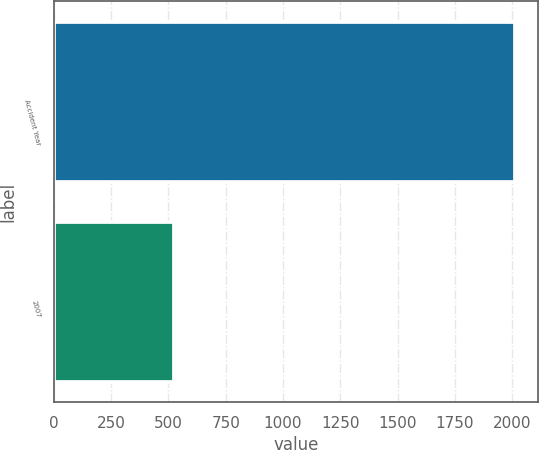Convert chart. <chart><loc_0><loc_0><loc_500><loc_500><bar_chart><fcel>Accident Year<fcel>2007<nl><fcel>2011<fcel>525<nl></chart> 